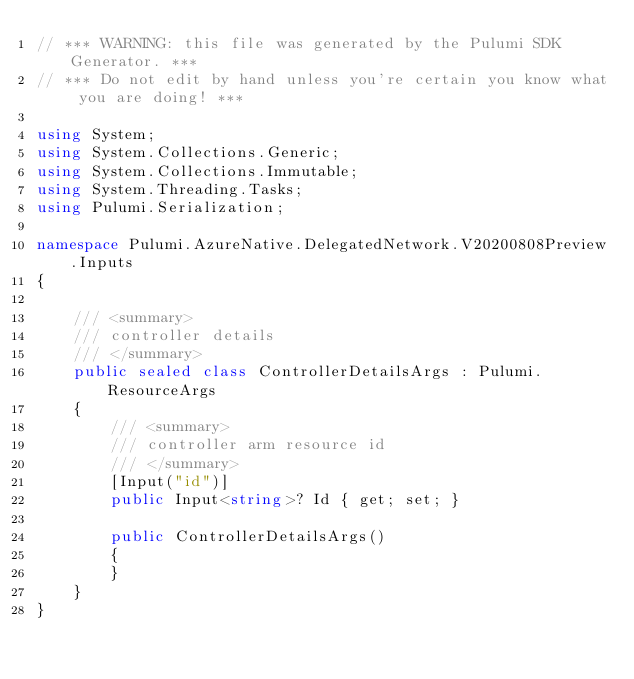<code> <loc_0><loc_0><loc_500><loc_500><_C#_>// *** WARNING: this file was generated by the Pulumi SDK Generator. ***
// *** Do not edit by hand unless you're certain you know what you are doing! ***

using System;
using System.Collections.Generic;
using System.Collections.Immutable;
using System.Threading.Tasks;
using Pulumi.Serialization;

namespace Pulumi.AzureNative.DelegatedNetwork.V20200808Preview.Inputs
{

    /// <summary>
    /// controller details
    /// </summary>
    public sealed class ControllerDetailsArgs : Pulumi.ResourceArgs
    {
        /// <summary>
        /// controller arm resource id
        /// </summary>
        [Input("id")]
        public Input<string>? Id { get; set; }

        public ControllerDetailsArgs()
        {
        }
    }
}
</code> 